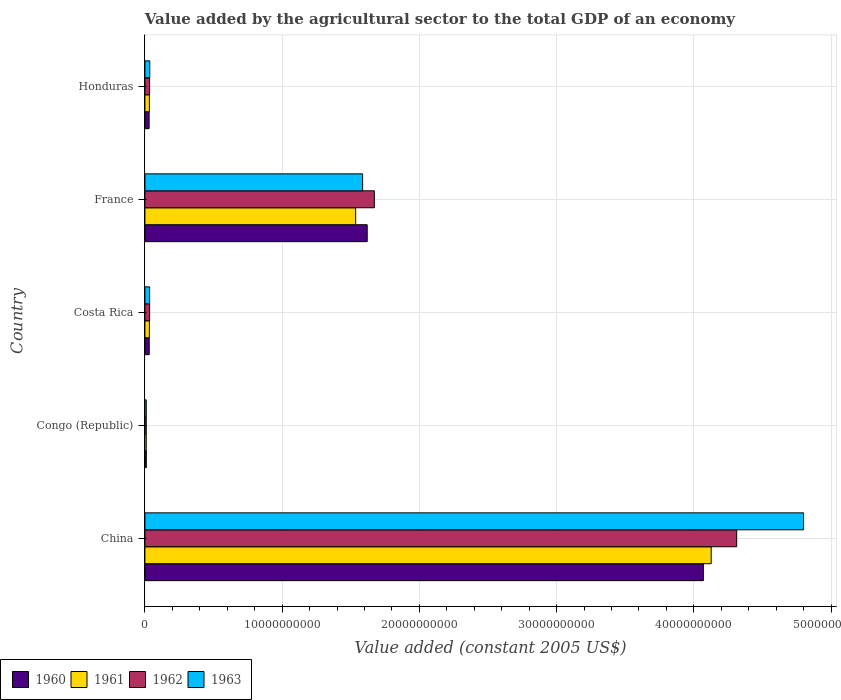How many different coloured bars are there?
Keep it short and to the point. 4. How many groups of bars are there?
Provide a succinct answer. 5. How many bars are there on the 1st tick from the top?
Your response must be concise. 4. In how many cases, is the number of bars for a given country not equal to the number of legend labels?
Provide a short and direct response. 0. What is the value added by the agricultural sector in 1962 in Congo (Republic)?
Provide a succinct answer. 9.79e+07. Across all countries, what is the maximum value added by the agricultural sector in 1963?
Provide a succinct answer. 4.80e+1. Across all countries, what is the minimum value added by the agricultural sector in 1960?
Your answer should be very brief. 1.01e+08. In which country was the value added by the agricultural sector in 1960 maximum?
Provide a succinct answer. China. In which country was the value added by the agricultural sector in 1962 minimum?
Your answer should be compact. Congo (Republic). What is the total value added by the agricultural sector in 1961 in the graph?
Your response must be concise. 5.74e+1. What is the difference between the value added by the agricultural sector in 1960 in China and that in France?
Your answer should be compact. 2.45e+1. What is the difference between the value added by the agricultural sector in 1961 in Honduras and the value added by the agricultural sector in 1960 in China?
Offer a very short reply. -4.04e+1. What is the average value added by the agricultural sector in 1963 per country?
Your answer should be compact. 1.29e+1. What is the difference between the value added by the agricultural sector in 1960 and value added by the agricultural sector in 1963 in Honduras?
Offer a terse response. -4.78e+07. What is the ratio of the value added by the agricultural sector in 1962 in Costa Rica to that in Honduras?
Offer a terse response. 1.01. Is the difference between the value added by the agricultural sector in 1960 in China and France greater than the difference between the value added by the agricultural sector in 1963 in China and France?
Keep it short and to the point. No. What is the difference between the highest and the second highest value added by the agricultural sector in 1960?
Keep it short and to the point. 2.45e+1. What is the difference between the highest and the lowest value added by the agricultural sector in 1961?
Provide a short and direct response. 4.12e+1. In how many countries, is the value added by the agricultural sector in 1960 greater than the average value added by the agricultural sector in 1960 taken over all countries?
Offer a very short reply. 2. Is it the case that in every country, the sum of the value added by the agricultural sector in 1963 and value added by the agricultural sector in 1962 is greater than the sum of value added by the agricultural sector in 1961 and value added by the agricultural sector in 1960?
Your answer should be very brief. No. Is it the case that in every country, the sum of the value added by the agricultural sector in 1961 and value added by the agricultural sector in 1962 is greater than the value added by the agricultural sector in 1960?
Keep it short and to the point. Yes. Are all the bars in the graph horizontal?
Ensure brevity in your answer.  Yes. Are the values on the major ticks of X-axis written in scientific E-notation?
Your response must be concise. No. Does the graph contain any zero values?
Provide a succinct answer. No. Does the graph contain grids?
Your response must be concise. Yes. Where does the legend appear in the graph?
Offer a very short reply. Bottom left. How many legend labels are there?
Offer a terse response. 4. What is the title of the graph?
Provide a succinct answer. Value added by the agricultural sector to the total GDP of an economy. Does "1969" appear as one of the legend labels in the graph?
Offer a very short reply. No. What is the label or title of the X-axis?
Make the answer very short. Value added (constant 2005 US$). What is the Value added (constant 2005 US$) in 1960 in China?
Your response must be concise. 4.07e+1. What is the Value added (constant 2005 US$) in 1961 in China?
Your response must be concise. 4.13e+1. What is the Value added (constant 2005 US$) of 1962 in China?
Provide a short and direct response. 4.31e+1. What is the Value added (constant 2005 US$) in 1963 in China?
Keep it short and to the point. 4.80e+1. What is the Value added (constant 2005 US$) of 1960 in Congo (Republic)?
Make the answer very short. 1.01e+08. What is the Value added (constant 2005 US$) in 1961 in Congo (Republic)?
Make the answer very short. 9.74e+07. What is the Value added (constant 2005 US$) of 1962 in Congo (Republic)?
Make the answer very short. 9.79e+07. What is the Value added (constant 2005 US$) of 1963 in Congo (Republic)?
Your answer should be very brief. 9.86e+07. What is the Value added (constant 2005 US$) of 1960 in Costa Rica?
Ensure brevity in your answer.  3.13e+08. What is the Value added (constant 2005 US$) in 1961 in Costa Rica?
Keep it short and to the point. 3.24e+08. What is the Value added (constant 2005 US$) in 1962 in Costa Rica?
Offer a very short reply. 3.44e+08. What is the Value added (constant 2005 US$) of 1963 in Costa Rica?
Your answer should be compact. 3.43e+08. What is the Value added (constant 2005 US$) of 1960 in France?
Ensure brevity in your answer.  1.62e+1. What is the Value added (constant 2005 US$) in 1961 in France?
Your answer should be very brief. 1.54e+1. What is the Value added (constant 2005 US$) of 1962 in France?
Provide a succinct answer. 1.67e+1. What is the Value added (constant 2005 US$) in 1963 in France?
Your response must be concise. 1.59e+1. What is the Value added (constant 2005 US$) in 1960 in Honduras?
Ensure brevity in your answer.  3.05e+08. What is the Value added (constant 2005 US$) in 1961 in Honduras?
Give a very brief answer. 3.25e+08. What is the Value added (constant 2005 US$) in 1962 in Honduras?
Offer a terse response. 3.41e+08. What is the Value added (constant 2005 US$) in 1963 in Honduras?
Offer a terse response. 3.53e+08. Across all countries, what is the maximum Value added (constant 2005 US$) in 1960?
Your answer should be compact. 4.07e+1. Across all countries, what is the maximum Value added (constant 2005 US$) in 1961?
Your response must be concise. 4.13e+1. Across all countries, what is the maximum Value added (constant 2005 US$) of 1962?
Your answer should be very brief. 4.31e+1. Across all countries, what is the maximum Value added (constant 2005 US$) of 1963?
Offer a terse response. 4.80e+1. Across all countries, what is the minimum Value added (constant 2005 US$) of 1960?
Your answer should be compact. 1.01e+08. Across all countries, what is the minimum Value added (constant 2005 US$) in 1961?
Provide a short and direct response. 9.74e+07. Across all countries, what is the minimum Value added (constant 2005 US$) in 1962?
Your answer should be compact. 9.79e+07. Across all countries, what is the minimum Value added (constant 2005 US$) in 1963?
Make the answer very short. 9.86e+07. What is the total Value added (constant 2005 US$) of 1960 in the graph?
Offer a terse response. 5.76e+1. What is the total Value added (constant 2005 US$) of 1961 in the graph?
Keep it short and to the point. 5.74e+1. What is the total Value added (constant 2005 US$) in 1962 in the graph?
Your answer should be very brief. 6.06e+1. What is the total Value added (constant 2005 US$) of 1963 in the graph?
Ensure brevity in your answer.  6.47e+1. What is the difference between the Value added (constant 2005 US$) in 1960 in China and that in Congo (Republic)?
Provide a succinct answer. 4.06e+1. What is the difference between the Value added (constant 2005 US$) in 1961 in China and that in Congo (Republic)?
Keep it short and to the point. 4.12e+1. What is the difference between the Value added (constant 2005 US$) of 1962 in China and that in Congo (Republic)?
Keep it short and to the point. 4.30e+1. What is the difference between the Value added (constant 2005 US$) in 1963 in China and that in Congo (Republic)?
Offer a very short reply. 4.79e+1. What is the difference between the Value added (constant 2005 US$) in 1960 in China and that in Costa Rica?
Your answer should be very brief. 4.04e+1. What is the difference between the Value added (constant 2005 US$) in 1961 in China and that in Costa Rica?
Your answer should be compact. 4.09e+1. What is the difference between the Value added (constant 2005 US$) of 1962 in China and that in Costa Rica?
Your answer should be compact. 4.28e+1. What is the difference between the Value added (constant 2005 US$) in 1963 in China and that in Costa Rica?
Ensure brevity in your answer.  4.77e+1. What is the difference between the Value added (constant 2005 US$) of 1960 in China and that in France?
Keep it short and to the point. 2.45e+1. What is the difference between the Value added (constant 2005 US$) of 1961 in China and that in France?
Keep it short and to the point. 2.59e+1. What is the difference between the Value added (constant 2005 US$) of 1962 in China and that in France?
Make the answer very short. 2.64e+1. What is the difference between the Value added (constant 2005 US$) of 1963 in China and that in France?
Provide a succinct answer. 3.21e+1. What is the difference between the Value added (constant 2005 US$) in 1960 in China and that in Honduras?
Provide a short and direct response. 4.04e+1. What is the difference between the Value added (constant 2005 US$) of 1961 in China and that in Honduras?
Provide a short and direct response. 4.09e+1. What is the difference between the Value added (constant 2005 US$) of 1962 in China and that in Honduras?
Your response must be concise. 4.28e+1. What is the difference between the Value added (constant 2005 US$) of 1963 in China and that in Honduras?
Your answer should be compact. 4.76e+1. What is the difference between the Value added (constant 2005 US$) in 1960 in Congo (Republic) and that in Costa Rica?
Offer a terse response. -2.12e+08. What is the difference between the Value added (constant 2005 US$) of 1961 in Congo (Republic) and that in Costa Rica?
Offer a very short reply. -2.27e+08. What is the difference between the Value added (constant 2005 US$) of 1962 in Congo (Republic) and that in Costa Rica?
Provide a short and direct response. -2.46e+08. What is the difference between the Value added (constant 2005 US$) in 1963 in Congo (Republic) and that in Costa Rica?
Your answer should be very brief. -2.45e+08. What is the difference between the Value added (constant 2005 US$) in 1960 in Congo (Republic) and that in France?
Offer a very short reply. -1.61e+1. What is the difference between the Value added (constant 2005 US$) of 1961 in Congo (Republic) and that in France?
Give a very brief answer. -1.53e+1. What is the difference between the Value added (constant 2005 US$) of 1962 in Congo (Republic) and that in France?
Offer a very short reply. -1.66e+1. What is the difference between the Value added (constant 2005 US$) of 1963 in Congo (Republic) and that in France?
Your response must be concise. -1.58e+1. What is the difference between the Value added (constant 2005 US$) of 1960 in Congo (Republic) and that in Honduras?
Give a very brief answer. -2.04e+08. What is the difference between the Value added (constant 2005 US$) in 1961 in Congo (Republic) and that in Honduras?
Your answer should be very brief. -2.28e+08. What is the difference between the Value added (constant 2005 US$) of 1962 in Congo (Republic) and that in Honduras?
Provide a succinct answer. -2.43e+08. What is the difference between the Value added (constant 2005 US$) of 1963 in Congo (Republic) and that in Honduras?
Make the answer very short. -2.55e+08. What is the difference between the Value added (constant 2005 US$) of 1960 in Costa Rica and that in France?
Offer a terse response. -1.59e+1. What is the difference between the Value added (constant 2005 US$) in 1961 in Costa Rica and that in France?
Offer a very short reply. -1.50e+1. What is the difference between the Value added (constant 2005 US$) of 1962 in Costa Rica and that in France?
Provide a short and direct response. -1.64e+1. What is the difference between the Value added (constant 2005 US$) of 1963 in Costa Rica and that in France?
Make the answer very short. -1.55e+1. What is the difference between the Value added (constant 2005 US$) in 1960 in Costa Rica and that in Honduras?
Provide a succinct answer. 7.61e+06. What is the difference between the Value added (constant 2005 US$) of 1961 in Costa Rica and that in Honduras?
Ensure brevity in your answer.  -8.14e+05. What is the difference between the Value added (constant 2005 US$) in 1962 in Costa Rica and that in Honduras?
Offer a very short reply. 3.61e+06. What is the difference between the Value added (constant 2005 US$) in 1963 in Costa Rica and that in Honduras?
Offer a terse response. -9.78e+06. What is the difference between the Value added (constant 2005 US$) in 1960 in France and that in Honduras?
Your answer should be very brief. 1.59e+1. What is the difference between the Value added (constant 2005 US$) of 1961 in France and that in Honduras?
Offer a terse response. 1.50e+1. What is the difference between the Value added (constant 2005 US$) of 1962 in France and that in Honduras?
Your answer should be compact. 1.64e+1. What is the difference between the Value added (constant 2005 US$) in 1963 in France and that in Honduras?
Keep it short and to the point. 1.55e+1. What is the difference between the Value added (constant 2005 US$) in 1960 in China and the Value added (constant 2005 US$) in 1961 in Congo (Republic)?
Your answer should be very brief. 4.06e+1. What is the difference between the Value added (constant 2005 US$) of 1960 in China and the Value added (constant 2005 US$) of 1962 in Congo (Republic)?
Keep it short and to the point. 4.06e+1. What is the difference between the Value added (constant 2005 US$) of 1960 in China and the Value added (constant 2005 US$) of 1963 in Congo (Republic)?
Provide a succinct answer. 4.06e+1. What is the difference between the Value added (constant 2005 US$) in 1961 in China and the Value added (constant 2005 US$) in 1962 in Congo (Republic)?
Your answer should be very brief. 4.12e+1. What is the difference between the Value added (constant 2005 US$) in 1961 in China and the Value added (constant 2005 US$) in 1963 in Congo (Republic)?
Your response must be concise. 4.12e+1. What is the difference between the Value added (constant 2005 US$) of 1962 in China and the Value added (constant 2005 US$) of 1963 in Congo (Republic)?
Make the answer very short. 4.30e+1. What is the difference between the Value added (constant 2005 US$) of 1960 in China and the Value added (constant 2005 US$) of 1961 in Costa Rica?
Your answer should be compact. 4.04e+1. What is the difference between the Value added (constant 2005 US$) of 1960 in China and the Value added (constant 2005 US$) of 1962 in Costa Rica?
Your response must be concise. 4.04e+1. What is the difference between the Value added (constant 2005 US$) in 1960 in China and the Value added (constant 2005 US$) in 1963 in Costa Rica?
Your response must be concise. 4.04e+1. What is the difference between the Value added (constant 2005 US$) in 1961 in China and the Value added (constant 2005 US$) in 1962 in Costa Rica?
Your answer should be compact. 4.09e+1. What is the difference between the Value added (constant 2005 US$) in 1961 in China and the Value added (constant 2005 US$) in 1963 in Costa Rica?
Provide a short and direct response. 4.09e+1. What is the difference between the Value added (constant 2005 US$) of 1962 in China and the Value added (constant 2005 US$) of 1963 in Costa Rica?
Offer a terse response. 4.28e+1. What is the difference between the Value added (constant 2005 US$) in 1960 in China and the Value added (constant 2005 US$) in 1961 in France?
Offer a very short reply. 2.53e+1. What is the difference between the Value added (constant 2005 US$) in 1960 in China and the Value added (constant 2005 US$) in 1962 in France?
Offer a terse response. 2.40e+1. What is the difference between the Value added (constant 2005 US$) of 1960 in China and the Value added (constant 2005 US$) of 1963 in France?
Provide a succinct answer. 2.48e+1. What is the difference between the Value added (constant 2005 US$) of 1961 in China and the Value added (constant 2005 US$) of 1962 in France?
Ensure brevity in your answer.  2.45e+1. What is the difference between the Value added (constant 2005 US$) in 1961 in China and the Value added (constant 2005 US$) in 1963 in France?
Keep it short and to the point. 2.54e+1. What is the difference between the Value added (constant 2005 US$) of 1962 in China and the Value added (constant 2005 US$) of 1963 in France?
Give a very brief answer. 2.73e+1. What is the difference between the Value added (constant 2005 US$) of 1960 in China and the Value added (constant 2005 US$) of 1961 in Honduras?
Offer a terse response. 4.04e+1. What is the difference between the Value added (constant 2005 US$) of 1960 in China and the Value added (constant 2005 US$) of 1962 in Honduras?
Your response must be concise. 4.04e+1. What is the difference between the Value added (constant 2005 US$) in 1960 in China and the Value added (constant 2005 US$) in 1963 in Honduras?
Make the answer very short. 4.03e+1. What is the difference between the Value added (constant 2005 US$) of 1961 in China and the Value added (constant 2005 US$) of 1962 in Honduras?
Offer a terse response. 4.09e+1. What is the difference between the Value added (constant 2005 US$) in 1961 in China and the Value added (constant 2005 US$) in 1963 in Honduras?
Offer a very short reply. 4.09e+1. What is the difference between the Value added (constant 2005 US$) of 1962 in China and the Value added (constant 2005 US$) of 1963 in Honduras?
Ensure brevity in your answer.  4.28e+1. What is the difference between the Value added (constant 2005 US$) in 1960 in Congo (Republic) and the Value added (constant 2005 US$) in 1961 in Costa Rica?
Give a very brief answer. -2.24e+08. What is the difference between the Value added (constant 2005 US$) of 1960 in Congo (Republic) and the Value added (constant 2005 US$) of 1962 in Costa Rica?
Provide a succinct answer. -2.43e+08. What is the difference between the Value added (constant 2005 US$) of 1960 in Congo (Republic) and the Value added (constant 2005 US$) of 1963 in Costa Rica?
Offer a very short reply. -2.42e+08. What is the difference between the Value added (constant 2005 US$) of 1961 in Congo (Republic) and the Value added (constant 2005 US$) of 1962 in Costa Rica?
Your response must be concise. -2.47e+08. What is the difference between the Value added (constant 2005 US$) in 1961 in Congo (Republic) and the Value added (constant 2005 US$) in 1963 in Costa Rica?
Make the answer very short. -2.46e+08. What is the difference between the Value added (constant 2005 US$) in 1962 in Congo (Republic) and the Value added (constant 2005 US$) in 1963 in Costa Rica?
Your answer should be very brief. -2.45e+08. What is the difference between the Value added (constant 2005 US$) in 1960 in Congo (Republic) and the Value added (constant 2005 US$) in 1961 in France?
Your response must be concise. -1.53e+1. What is the difference between the Value added (constant 2005 US$) of 1960 in Congo (Republic) and the Value added (constant 2005 US$) of 1962 in France?
Your response must be concise. -1.66e+1. What is the difference between the Value added (constant 2005 US$) of 1960 in Congo (Republic) and the Value added (constant 2005 US$) of 1963 in France?
Your answer should be compact. -1.58e+1. What is the difference between the Value added (constant 2005 US$) of 1961 in Congo (Republic) and the Value added (constant 2005 US$) of 1962 in France?
Offer a terse response. -1.66e+1. What is the difference between the Value added (constant 2005 US$) of 1961 in Congo (Republic) and the Value added (constant 2005 US$) of 1963 in France?
Ensure brevity in your answer.  -1.58e+1. What is the difference between the Value added (constant 2005 US$) in 1962 in Congo (Republic) and the Value added (constant 2005 US$) in 1963 in France?
Provide a succinct answer. -1.58e+1. What is the difference between the Value added (constant 2005 US$) of 1960 in Congo (Republic) and the Value added (constant 2005 US$) of 1961 in Honduras?
Offer a very short reply. -2.24e+08. What is the difference between the Value added (constant 2005 US$) in 1960 in Congo (Republic) and the Value added (constant 2005 US$) in 1962 in Honduras?
Provide a succinct answer. -2.40e+08. What is the difference between the Value added (constant 2005 US$) in 1960 in Congo (Republic) and the Value added (constant 2005 US$) in 1963 in Honduras?
Your answer should be very brief. -2.52e+08. What is the difference between the Value added (constant 2005 US$) of 1961 in Congo (Republic) and the Value added (constant 2005 US$) of 1962 in Honduras?
Offer a terse response. -2.43e+08. What is the difference between the Value added (constant 2005 US$) of 1961 in Congo (Republic) and the Value added (constant 2005 US$) of 1963 in Honduras?
Your answer should be compact. -2.56e+08. What is the difference between the Value added (constant 2005 US$) of 1962 in Congo (Republic) and the Value added (constant 2005 US$) of 1963 in Honduras?
Provide a short and direct response. -2.55e+08. What is the difference between the Value added (constant 2005 US$) in 1960 in Costa Rica and the Value added (constant 2005 US$) in 1961 in France?
Keep it short and to the point. -1.50e+1. What is the difference between the Value added (constant 2005 US$) in 1960 in Costa Rica and the Value added (constant 2005 US$) in 1962 in France?
Provide a succinct answer. -1.64e+1. What is the difference between the Value added (constant 2005 US$) of 1960 in Costa Rica and the Value added (constant 2005 US$) of 1963 in France?
Make the answer very short. -1.56e+1. What is the difference between the Value added (constant 2005 US$) in 1961 in Costa Rica and the Value added (constant 2005 US$) in 1962 in France?
Provide a short and direct response. -1.64e+1. What is the difference between the Value added (constant 2005 US$) in 1961 in Costa Rica and the Value added (constant 2005 US$) in 1963 in France?
Your response must be concise. -1.55e+1. What is the difference between the Value added (constant 2005 US$) in 1962 in Costa Rica and the Value added (constant 2005 US$) in 1963 in France?
Keep it short and to the point. -1.55e+1. What is the difference between the Value added (constant 2005 US$) in 1960 in Costa Rica and the Value added (constant 2005 US$) in 1961 in Honduras?
Give a very brief answer. -1.23e+07. What is the difference between the Value added (constant 2005 US$) of 1960 in Costa Rica and the Value added (constant 2005 US$) of 1962 in Honduras?
Your answer should be very brief. -2.78e+07. What is the difference between the Value added (constant 2005 US$) of 1960 in Costa Rica and the Value added (constant 2005 US$) of 1963 in Honduras?
Provide a short and direct response. -4.02e+07. What is the difference between the Value added (constant 2005 US$) of 1961 in Costa Rica and the Value added (constant 2005 US$) of 1962 in Honduras?
Provide a succinct answer. -1.63e+07. What is the difference between the Value added (constant 2005 US$) in 1961 in Costa Rica and the Value added (constant 2005 US$) in 1963 in Honduras?
Provide a short and direct response. -2.87e+07. What is the difference between the Value added (constant 2005 US$) of 1962 in Costa Rica and the Value added (constant 2005 US$) of 1963 in Honduras?
Your answer should be very brief. -8.78e+06. What is the difference between the Value added (constant 2005 US$) in 1960 in France and the Value added (constant 2005 US$) in 1961 in Honduras?
Offer a terse response. 1.59e+1. What is the difference between the Value added (constant 2005 US$) in 1960 in France and the Value added (constant 2005 US$) in 1962 in Honduras?
Make the answer very short. 1.59e+1. What is the difference between the Value added (constant 2005 US$) in 1960 in France and the Value added (constant 2005 US$) in 1963 in Honduras?
Offer a terse response. 1.58e+1. What is the difference between the Value added (constant 2005 US$) in 1961 in France and the Value added (constant 2005 US$) in 1962 in Honduras?
Keep it short and to the point. 1.50e+1. What is the difference between the Value added (constant 2005 US$) in 1961 in France and the Value added (constant 2005 US$) in 1963 in Honduras?
Provide a short and direct response. 1.50e+1. What is the difference between the Value added (constant 2005 US$) of 1962 in France and the Value added (constant 2005 US$) of 1963 in Honduras?
Give a very brief answer. 1.64e+1. What is the average Value added (constant 2005 US$) in 1960 per country?
Give a very brief answer. 1.15e+1. What is the average Value added (constant 2005 US$) of 1961 per country?
Your answer should be very brief. 1.15e+1. What is the average Value added (constant 2005 US$) in 1962 per country?
Offer a very short reply. 1.21e+1. What is the average Value added (constant 2005 US$) of 1963 per country?
Keep it short and to the point. 1.29e+1. What is the difference between the Value added (constant 2005 US$) of 1960 and Value added (constant 2005 US$) of 1961 in China?
Offer a terse response. -5.70e+08. What is the difference between the Value added (constant 2005 US$) in 1960 and Value added (constant 2005 US$) in 1962 in China?
Offer a terse response. -2.43e+09. What is the difference between the Value added (constant 2005 US$) of 1960 and Value added (constant 2005 US$) of 1963 in China?
Provide a succinct answer. -7.30e+09. What is the difference between the Value added (constant 2005 US$) of 1961 and Value added (constant 2005 US$) of 1962 in China?
Give a very brief answer. -1.86e+09. What is the difference between the Value added (constant 2005 US$) in 1961 and Value added (constant 2005 US$) in 1963 in China?
Give a very brief answer. -6.73e+09. What is the difference between the Value added (constant 2005 US$) of 1962 and Value added (constant 2005 US$) of 1963 in China?
Your answer should be very brief. -4.87e+09. What is the difference between the Value added (constant 2005 US$) of 1960 and Value added (constant 2005 US$) of 1961 in Congo (Republic)?
Give a very brief answer. 3.61e+06. What is the difference between the Value added (constant 2005 US$) of 1960 and Value added (constant 2005 US$) of 1962 in Congo (Republic)?
Offer a terse response. 3.02e+06. What is the difference between the Value added (constant 2005 US$) in 1960 and Value added (constant 2005 US$) in 1963 in Congo (Republic)?
Your response must be concise. 2.34e+06. What is the difference between the Value added (constant 2005 US$) of 1961 and Value added (constant 2005 US$) of 1962 in Congo (Republic)?
Offer a terse response. -5.86e+05. What is the difference between the Value added (constant 2005 US$) of 1961 and Value added (constant 2005 US$) of 1963 in Congo (Republic)?
Your answer should be very brief. -1.27e+06. What is the difference between the Value added (constant 2005 US$) of 1962 and Value added (constant 2005 US$) of 1963 in Congo (Republic)?
Give a very brief answer. -6.85e+05. What is the difference between the Value added (constant 2005 US$) in 1960 and Value added (constant 2005 US$) in 1961 in Costa Rica?
Your answer should be very brief. -1.15e+07. What is the difference between the Value added (constant 2005 US$) of 1960 and Value added (constant 2005 US$) of 1962 in Costa Rica?
Make the answer very short. -3.14e+07. What is the difference between the Value added (constant 2005 US$) of 1960 and Value added (constant 2005 US$) of 1963 in Costa Rica?
Ensure brevity in your answer.  -3.04e+07. What is the difference between the Value added (constant 2005 US$) in 1961 and Value added (constant 2005 US$) in 1962 in Costa Rica?
Ensure brevity in your answer.  -1.99e+07. What is the difference between the Value added (constant 2005 US$) of 1961 and Value added (constant 2005 US$) of 1963 in Costa Rica?
Make the answer very short. -1.89e+07. What is the difference between the Value added (constant 2005 US$) in 1962 and Value added (constant 2005 US$) in 1963 in Costa Rica?
Ensure brevity in your answer.  1.00e+06. What is the difference between the Value added (constant 2005 US$) in 1960 and Value added (constant 2005 US$) in 1961 in France?
Provide a succinct answer. 8.42e+08. What is the difference between the Value added (constant 2005 US$) of 1960 and Value added (constant 2005 US$) of 1962 in France?
Keep it short and to the point. -5.20e+08. What is the difference between the Value added (constant 2005 US$) in 1960 and Value added (constant 2005 US$) in 1963 in France?
Provide a succinct answer. 3.35e+08. What is the difference between the Value added (constant 2005 US$) in 1961 and Value added (constant 2005 US$) in 1962 in France?
Your answer should be very brief. -1.36e+09. What is the difference between the Value added (constant 2005 US$) in 1961 and Value added (constant 2005 US$) in 1963 in France?
Keep it short and to the point. -5.07e+08. What is the difference between the Value added (constant 2005 US$) of 1962 and Value added (constant 2005 US$) of 1963 in France?
Your response must be concise. 8.56e+08. What is the difference between the Value added (constant 2005 US$) of 1960 and Value added (constant 2005 US$) of 1961 in Honduras?
Give a very brief answer. -1.99e+07. What is the difference between the Value added (constant 2005 US$) in 1960 and Value added (constant 2005 US$) in 1962 in Honduras?
Offer a very short reply. -3.54e+07. What is the difference between the Value added (constant 2005 US$) of 1960 and Value added (constant 2005 US$) of 1963 in Honduras?
Your response must be concise. -4.78e+07. What is the difference between the Value added (constant 2005 US$) in 1961 and Value added (constant 2005 US$) in 1962 in Honduras?
Give a very brief answer. -1.55e+07. What is the difference between the Value added (constant 2005 US$) of 1961 and Value added (constant 2005 US$) of 1963 in Honduras?
Keep it short and to the point. -2.79e+07. What is the difference between the Value added (constant 2005 US$) in 1962 and Value added (constant 2005 US$) in 1963 in Honduras?
Offer a terse response. -1.24e+07. What is the ratio of the Value added (constant 2005 US$) of 1960 in China to that in Congo (Republic)?
Provide a succinct answer. 403.12. What is the ratio of the Value added (constant 2005 US$) in 1961 in China to that in Congo (Republic)?
Provide a short and direct response. 423.9. What is the ratio of the Value added (constant 2005 US$) in 1962 in China to that in Congo (Republic)?
Ensure brevity in your answer.  440.32. What is the ratio of the Value added (constant 2005 US$) of 1963 in China to that in Congo (Republic)?
Offer a terse response. 486.68. What is the ratio of the Value added (constant 2005 US$) of 1960 in China to that in Costa Rica?
Your response must be concise. 130.03. What is the ratio of the Value added (constant 2005 US$) in 1961 in China to that in Costa Rica?
Provide a succinct answer. 127.18. What is the ratio of the Value added (constant 2005 US$) of 1962 in China to that in Costa Rica?
Keep it short and to the point. 125.23. What is the ratio of the Value added (constant 2005 US$) in 1963 in China to that in Costa Rica?
Your answer should be compact. 139.78. What is the ratio of the Value added (constant 2005 US$) in 1960 in China to that in France?
Ensure brevity in your answer.  2.51. What is the ratio of the Value added (constant 2005 US$) in 1961 in China to that in France?
Your answer should be compact. 2.69. What is the ratio of the Value added (constant 2005 US$) in 1962 in China to that in France?
Offer a terse response. 2.58. What is the ratio of the Value added (constant 2005 US$) in 1963 in China to that in France?
Offer a very short reply. 3.03. What is the ratio of the Value added (constant 2005 US$) in 1960 in China to that in Honduras?
Offer a very short reply. 133.27. What is the ratio of the Value added (constant 2005 US$) of 1961 in China to that in Honduras?
Give a very brief answer. 126.86. What is the ratio of the Value added (constant 2005 US$) in 1962 in China to that in Honduras?
Offer a very short reply. 126.55. What is the ratio of the Value added (constant 2005 US$) of 1963 in China to that in Honduras?
Keep it short and to the point. 135.91. What is the ratio of the Value added (constant 2005 US$) of 1960 in Congo (Republic) to that in Costa Rica?
Your answer should be very brief. 0.32. What is the ratio of the Value added (constant 2005 US$) in 1961 in Congo (Republic) to that in Costa Rica?
Give a very brief answer. 0.3. What is the ratio of the Value added (constant 2005 US$) of 1962 in Congo (Republic) to that in Costa Rica?
Ensure brevity in your answer.  0.28. What is the ratio of the Value added (constant 2005 US$) of 1963 in Congo (Republic) to that in Costa Rica?
Give a very brief answer. 0.29. What is the ratio of the Value added (constant 2005 US$) in 1960 in Congo (Republic) to that in France?
Your answer should be compact. 0.01. What is the ratio of the Value added (constant 2005 US$) of 1961 in Congo (Republic) to that in France?
Your answer should be compact. 0.01. What is the ratio of the Value added (constant 2005 US$) in 1962 in Congo (Republic) to that in France?
Your answer should be very brief. 0.01. What is the ratio of the Value added (constant 2005 US$) in 1963 in Congo (Republic) to that in France?
Give a very brief answer. 0.01. What is the ratio of the Value added (constant 2005 US$) in 1960 in Congo (Republic) to that in Honduras?
Keep it short and to the point. 0.33. What is the ratio of the Value added (constant 2005 US$) in 1961 in Congo (Republic) to that in Honduras?
Offer a very short reply. 0.3. What is the ratio of the Value added (constant 2005 US$) in 1962 in Congo (Republic) to that in Honduras?
Ensure brevity in your answer.  0.29. What is the ratio of the Value added (constant 2005 US$) in 1963 in Congo (Republic) to that in Honduras?
Your response must be concise. 0.28. What is the ratio of the Value added (constant 2005 US$) of 1960 in Costa Rica to that in France?
Offer a terse response. 0.02. What is the ratio of the Value added (constant 2005 US$) in 1961 in Costa Rica to that in France?
Offer a very short reply. 0.02. What is the ratio of the Value added (constant 2005 US$) in 1962 in Costa Rica to that in France?
Offer a terse response. 0.02. What is the ratio of the Value added (constant 2005 US$) in 1963 in Costa Rica to that in France?
Offer a very short reply. 0.02. What is the ratio of the Value added (constant 2005 US$) in 1960 in Costa Rica to that in Honduras?
Offer a very short reply. 1.02. What is the ratio of the Value added (constant 2005 US$) in 1961 in Costa Rica to that in Honduras?
Offer a terse response. 1. What is the ratio of the Value added (constant 2005 US$) of 1962 in Costa Rica to that in Honduras?
Make the answer very short. 1.01. What is the ratio of the Value added (constant 2005 US$) in 1963 in Costa Rica to that in Honduras?
Your response must be concise. 0.97. What is the ratio of the Value added (constant 2005 US$) of 1960 in France to that in Honduras?
Provide a succinct answer. 53.05. What is the ratio of the Value added (constant 2005 US$) of 1961 in France to that in Honduras?
Make the answer very short. 47.21. What is the ratio of the Value added (constant 2005 US$) in 1962 in France to that in Honduras?
Keep it short and to the point. 49.07. What is the ratio of the Value added (constant 2005 US$) in 1963 in France to that in Honduras?
Ensure brevity in your answer.  44.92. What is the difference between the highest and the second highest Value added (constant 2005 US$) in 1960?
Give a very brief answer. 2.45e+1. What is the difference between the highest and the second highest Value added (constant 2005 US$) of 1961?
Ensure brevity in your answer.  2.59e+1. What is the difference between the highest and the second highest Value added (constant 2005 US$) of 1962?
Offer a terse response. 2.64e+1. What is the difference between the highest and the second highest Value added (constant 2005 US$) in 1963?
Keep it short and to the point. 3.21e+1. What is the difference between the highest and the lowest Value added (constant 2005 US$) in 1960?
Offer a very short reply. 4.06e+1. What is the difference between the highest and the lowest Value added (constant 2005 US$) of 1961?
Give a very brief answer. 4.12e+1. What is the difference between the highest and the lowest Value added (constant 2005 US$) in 1962?
Give a very brief answer. 4.30e+1. What is the difference between the highest and the lowest Value added (constant 2005 US$) in 1963?
Ensure brevity in your answer.  4.79e+1. 